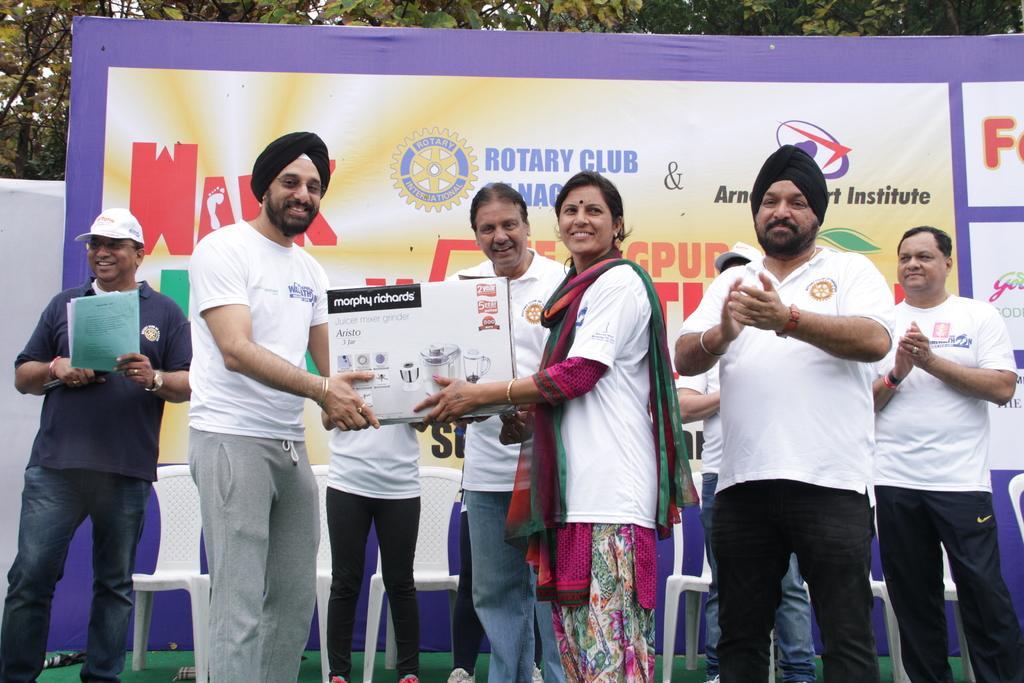Could you give a brief overview of what you see in this image? In this picture I can see few people are standing and I can see a man and a woman holding a box in their hands and I can see another man holding papers and I can see few chairs and an advertisement hoarding in the back with some text and I can see trees. 